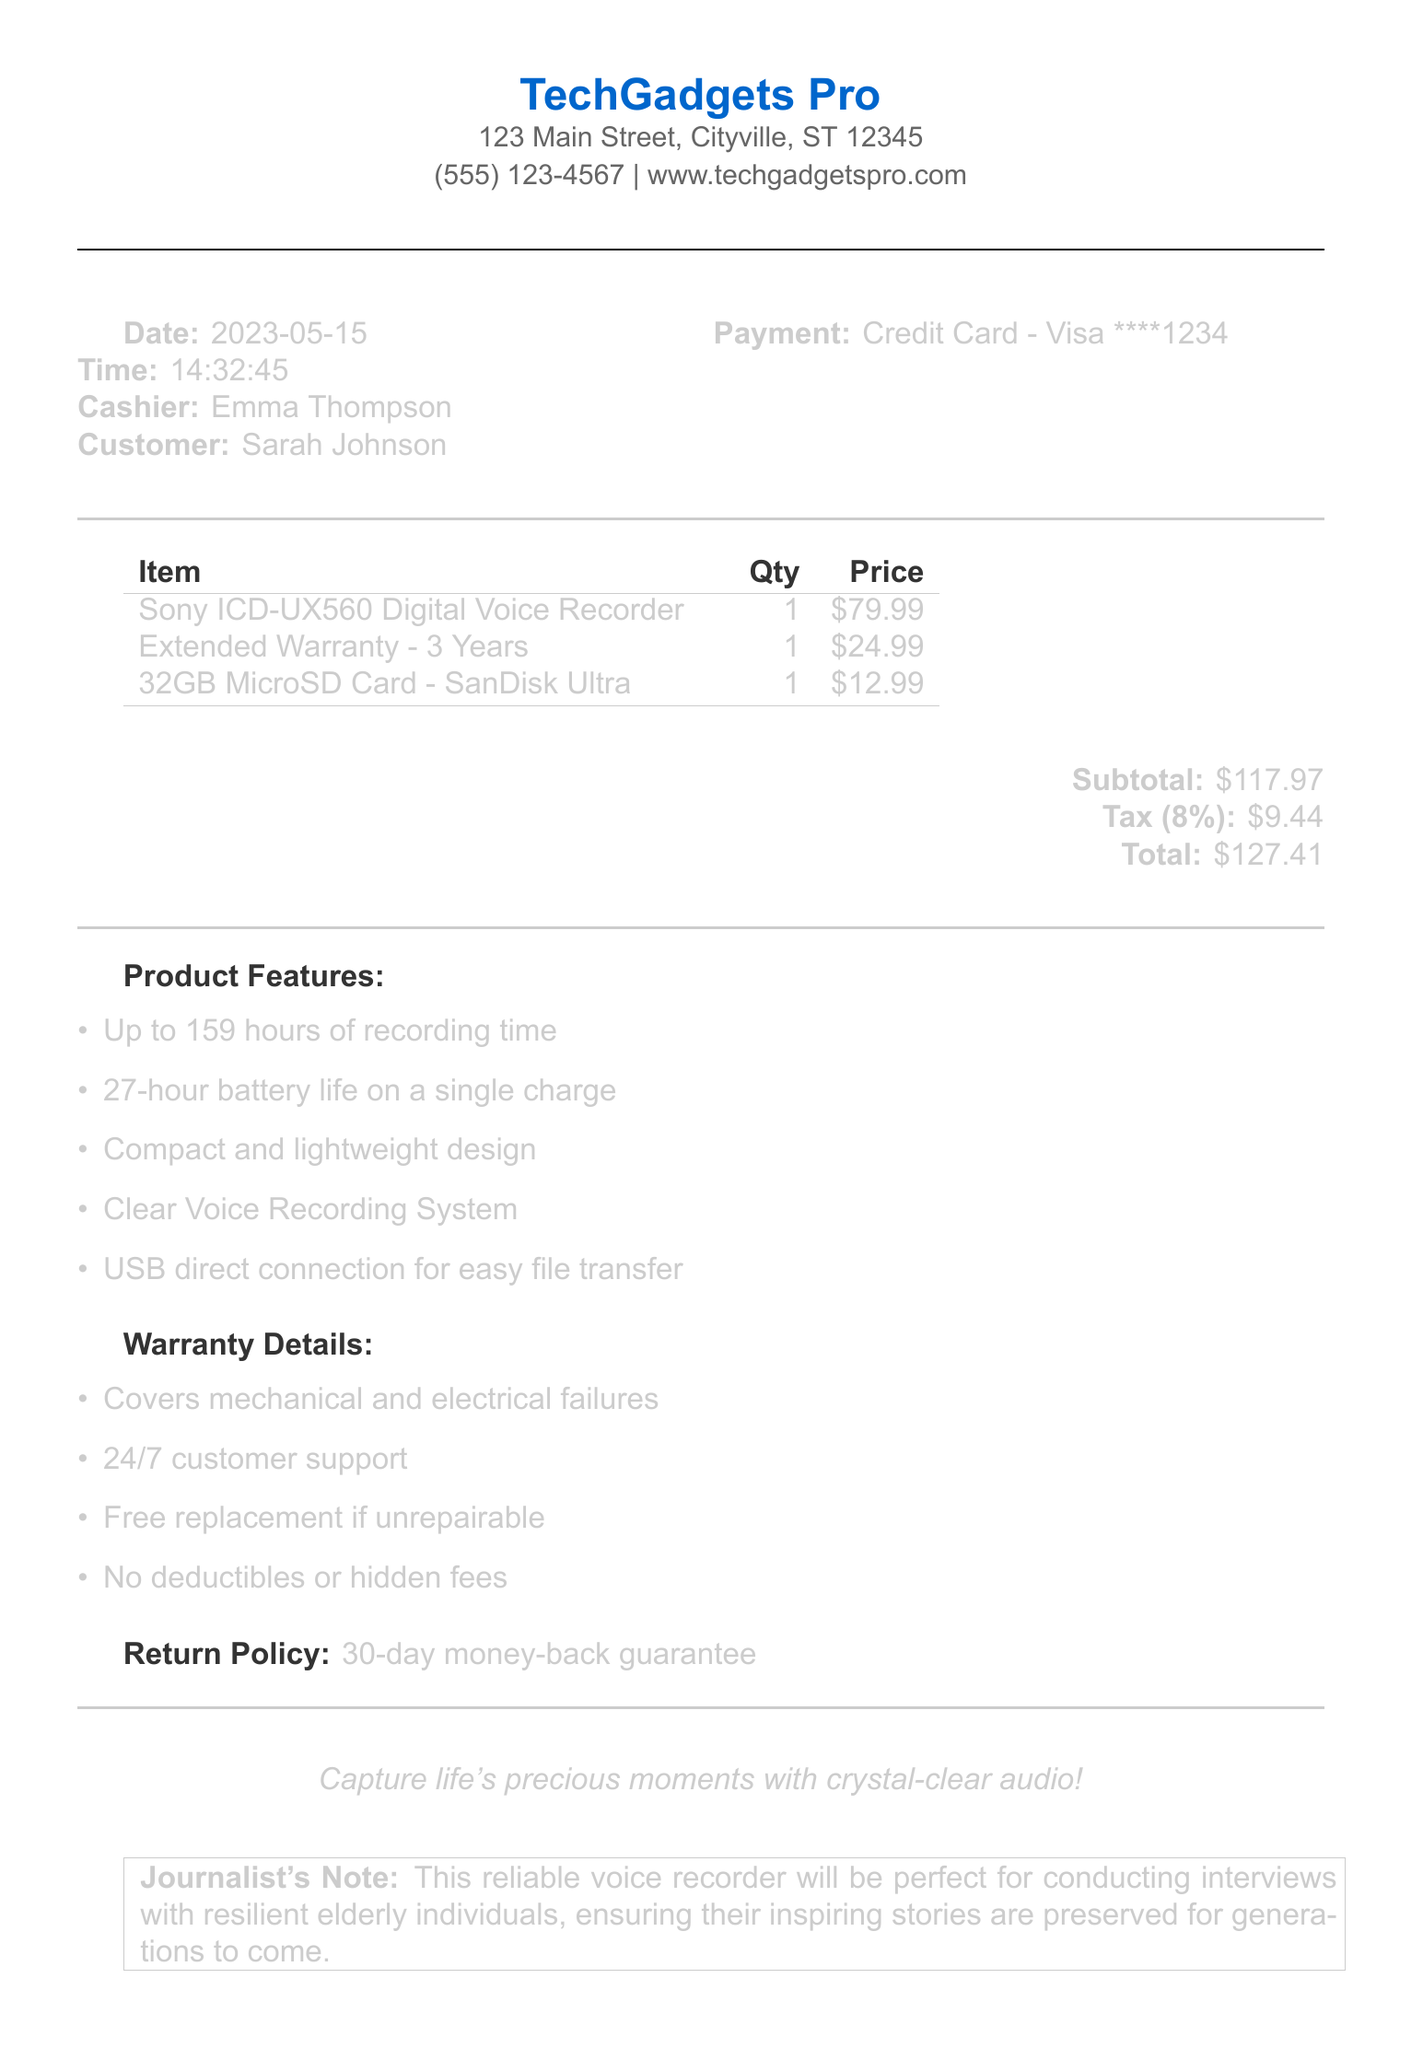What is the store name? The store name is provided at the top of the receipt, indicating where the purchase was made.
Answer: TechGadgets Pro What item has a 27-hour battery life? The battery life is mentioned in the product features section related to the specific item.
Answer: Sony ICD-UX560 Digital Voice Recorder What is the price of the extended warranty? The price for the extended warranty is listed under the items purchased in the receipt.
Answer: 24.99 What is the total amount paid? The total amount includes the subtotal, tax, and any other costs, summarized at the bottom of the receipt.
Answer: 127.41 How long is the warranty coverage? The duration of the extended warranty is mentioned in the item description on the receipt.
Answer: 3 Years What feature ensures crystal-clear audio? This specific feature is listed in the product features and indicates the quality of the recordings.
Answer: Clear Voice Recording System What return policy is mentioned? The return policy details how long a customer has to return items for a refund.
Answer: 30-day money-back guarantee What was the payment method used? The payment method describes how the purchase was completed, which is found near the customer information.
Answer: Credit Card - Visa ****1234 